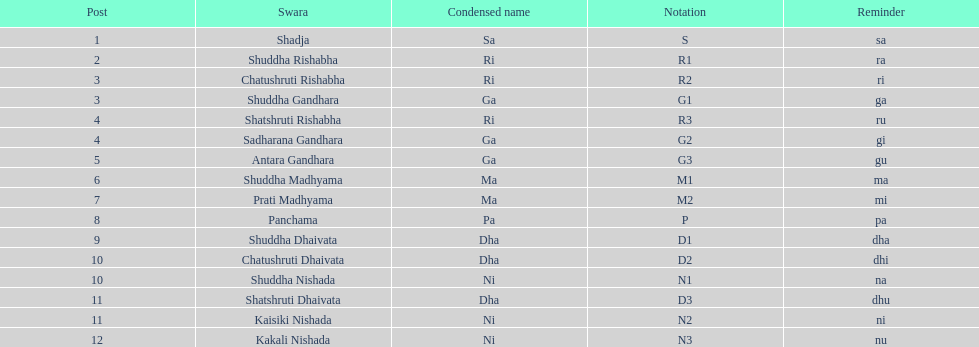Which swara holds the last position? Kakali Nishada. 